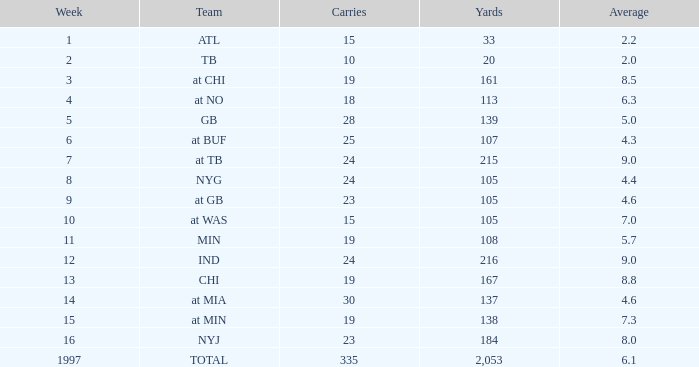5? None. 